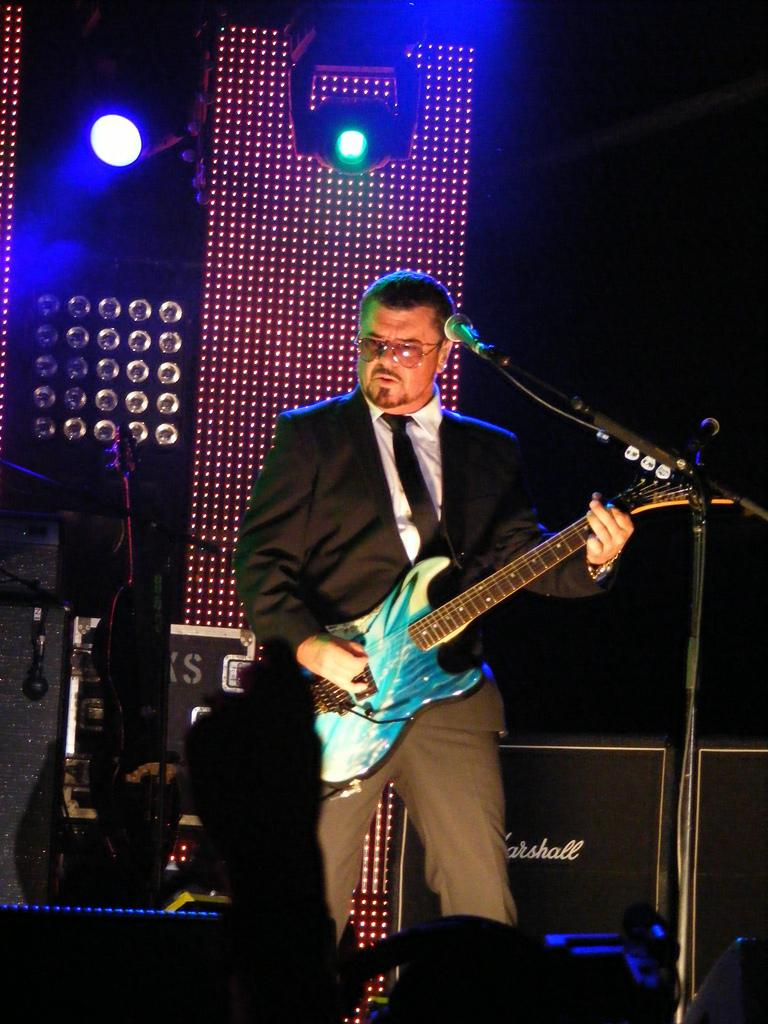Who is the person in the image? There is a man in the image. What is the man holding in the image? The man is holding a guitar. What object is in front of the man? There is a microphone in front of the man. What can be seen in the background of the image? There are lights in the background of the image. What type of sail can be seen in the image? There is no sail present in the image. What is the man's reaction to the spark in the image? There is no spark or reaction to a spark in the image. 